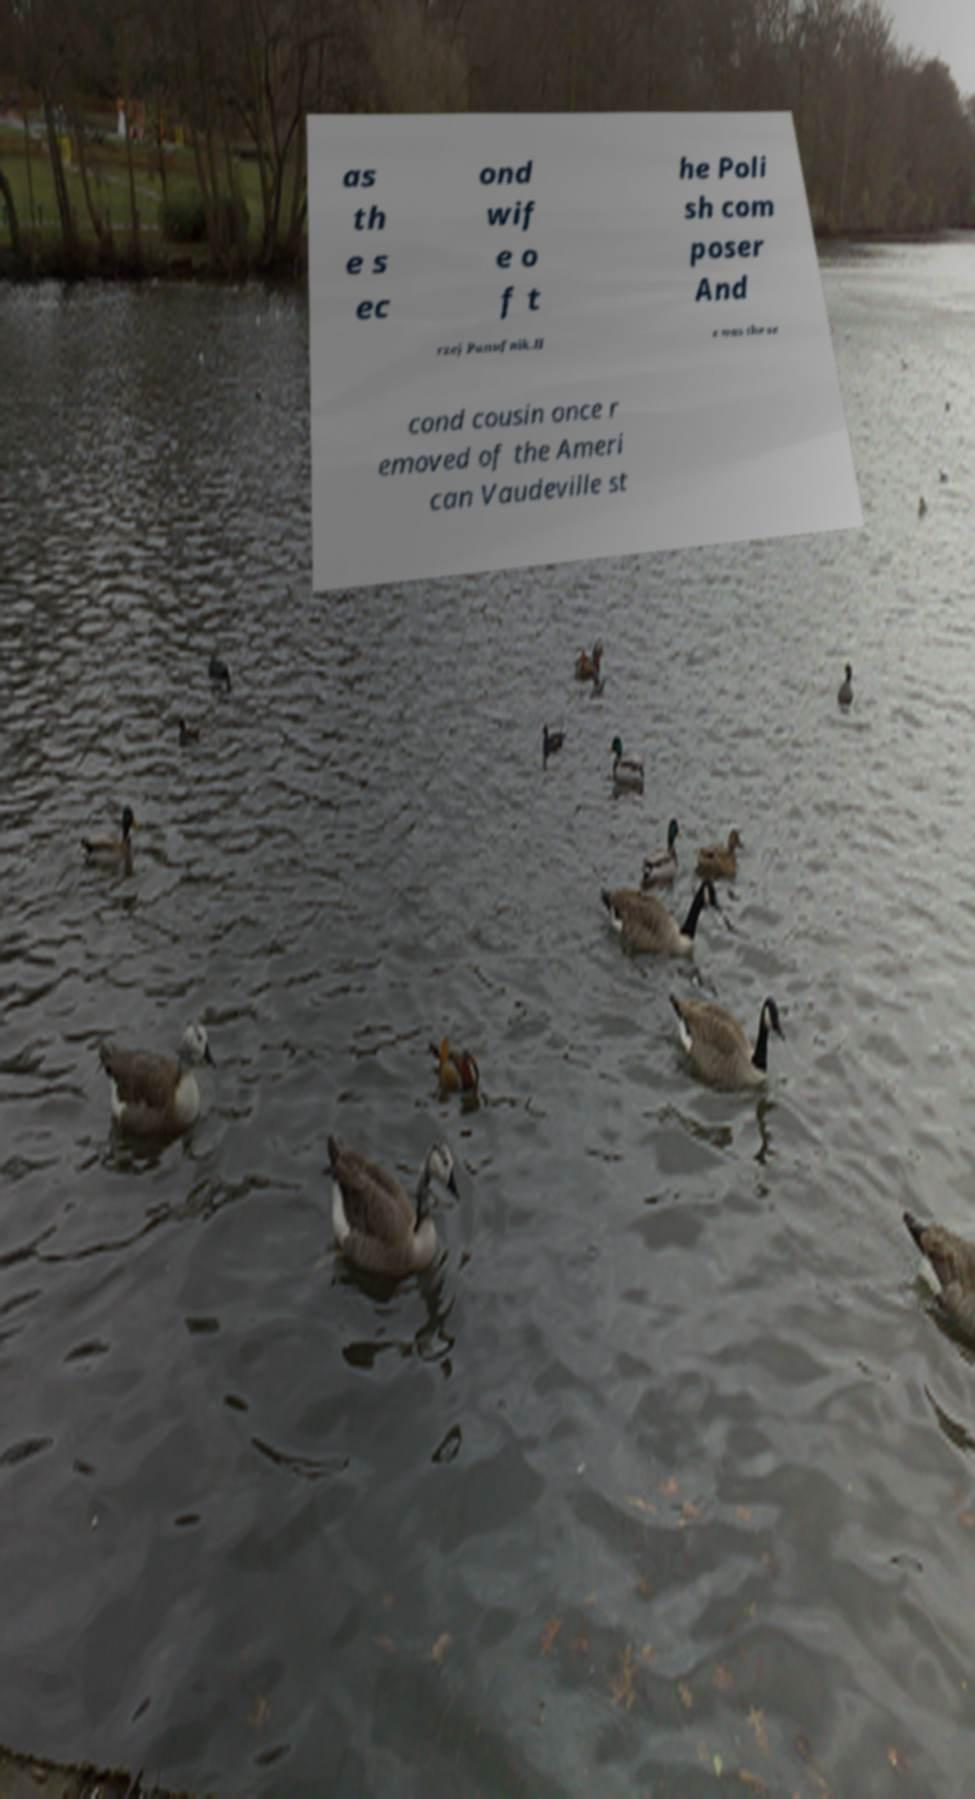Can you read and provide the text displayed in the image?This photo seems to have some interesting text. Can you extract and type it out for me? as th e s ec ond wif e o f t he Poli sh com poser And rzej Panufnik.H e was the se cond cousin once r emoved of the Ameri can Vaudeville st 